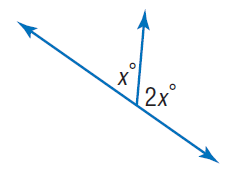Answer the mathemtical geometry problem and directly provide the correct option letter.
Question: Find x.
Choices: A: 30 B: 60 C: 120 D: 150 B 